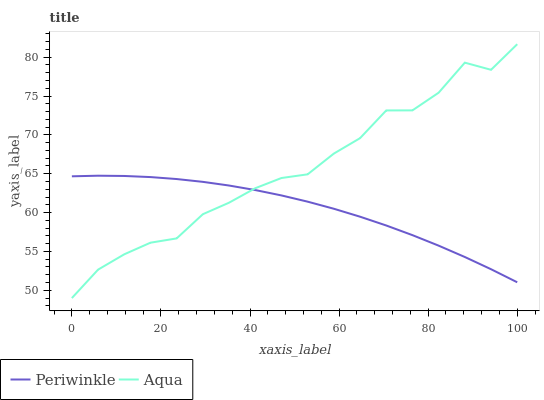Does Periwinkle have the maximum area under the curve?
Answer yes or no. No. Is Periwinkle the roughest?
Answer yes or no. No. Does Periwinkle have the lowest value?
Answer yes or no. No. Does Periwinkle have the highest value?
Answer yes or no. No. 